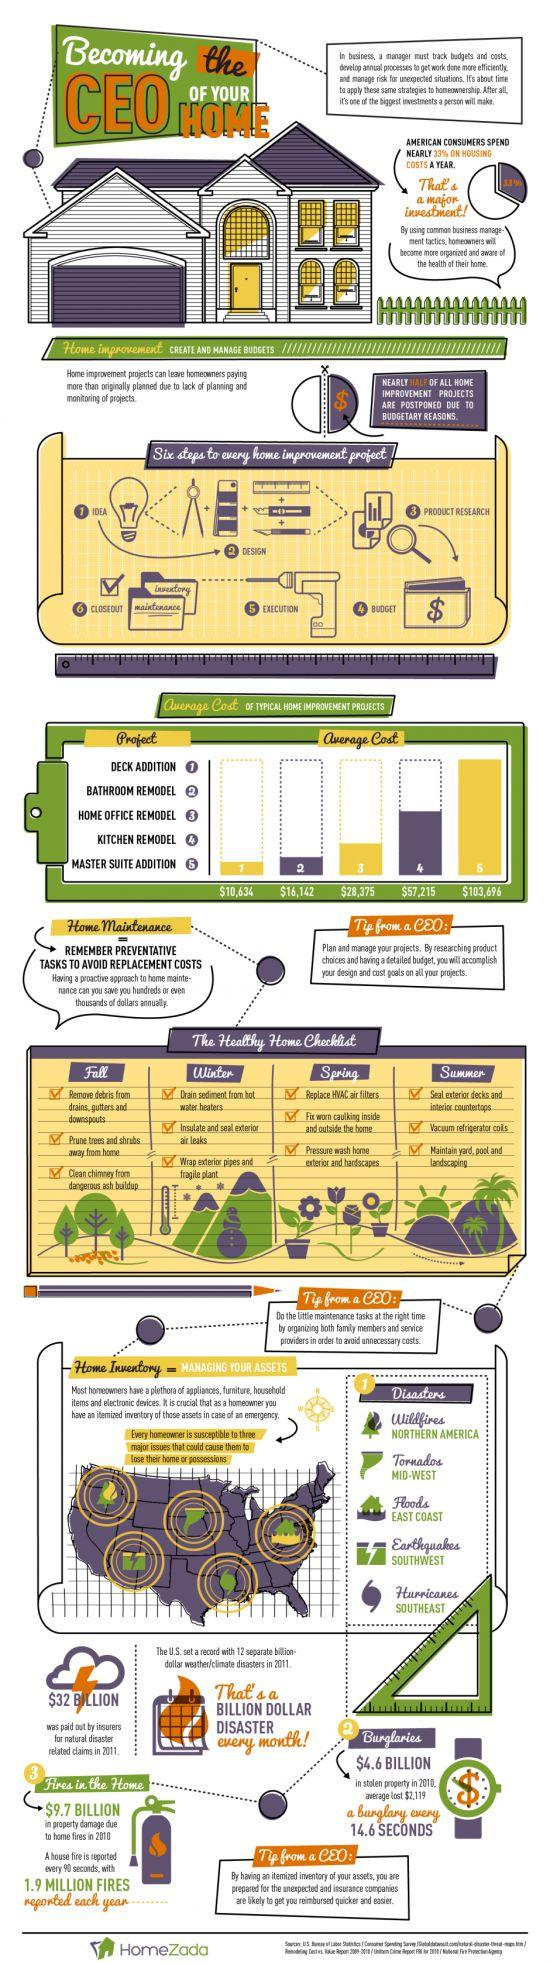Indicate a few pertinent items in this graphic. The deck addition home improvement project has the least average cost compared to the other options. The natural disaster in Southwest America that can cause people to lose their homes or possessions is earthquakes. In 2011, the amount paid by insurers for natural disaster-related claims was approximately $32 billion. In the United States, a significant portion of consumers' spending goes towards housing costs, with an estimated 33% of their annual budget allocated towards this expense. The master suite addition is the home improvement project that has the highest average cost. 